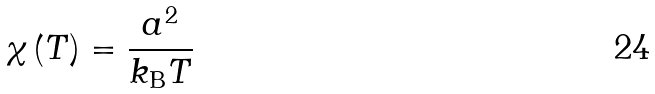Convert formula to latex. <formula><loc_0><loc_0><loc_500><loc_500>\chi \left ( T \right ) = \frac { a ^ { 2 } } { k _ { \text {B} } T }</formula> 